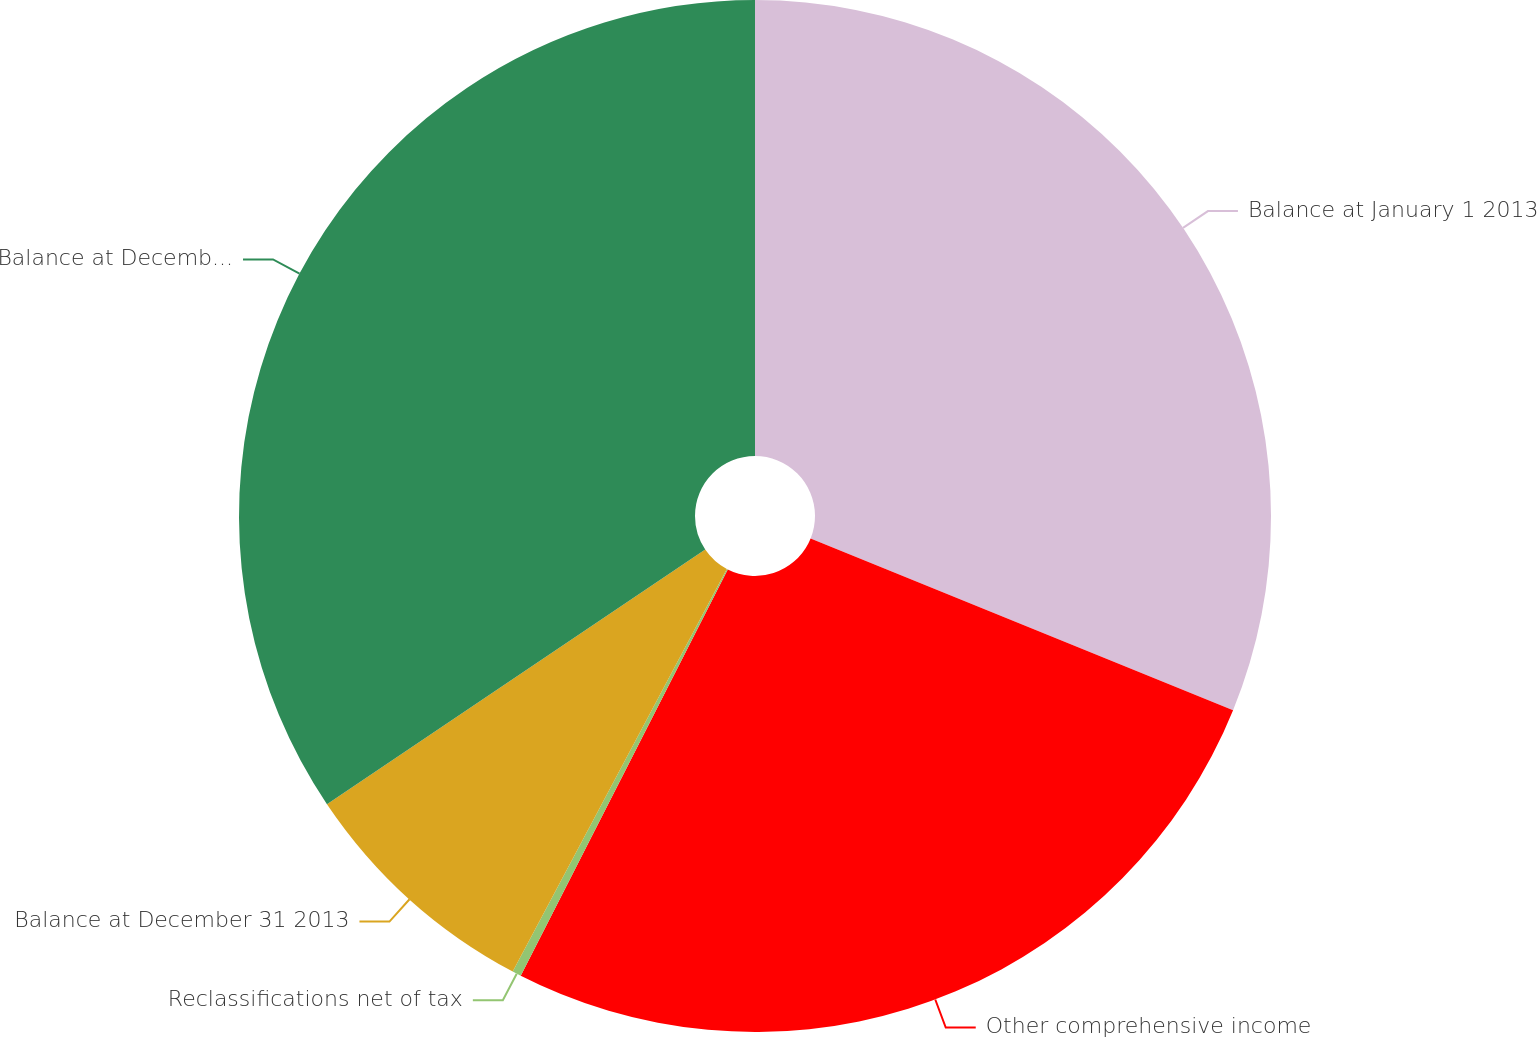Convert chart to OTSL. <chart><loc_0><loc_0><loc_500><loc_500><pie_chart><fcel>Balance at January 1 2013<fcel>Other comprehensive income<fcel>Reclassifications net of tax<fcel>Balance at December 31 2013<fcel>Balance at December 31 2014<nl><fcel>31.14%<fcel>26.36%<fcel>0.28%<fcel>7.79%<fcel>34.43%<nl></chart> 